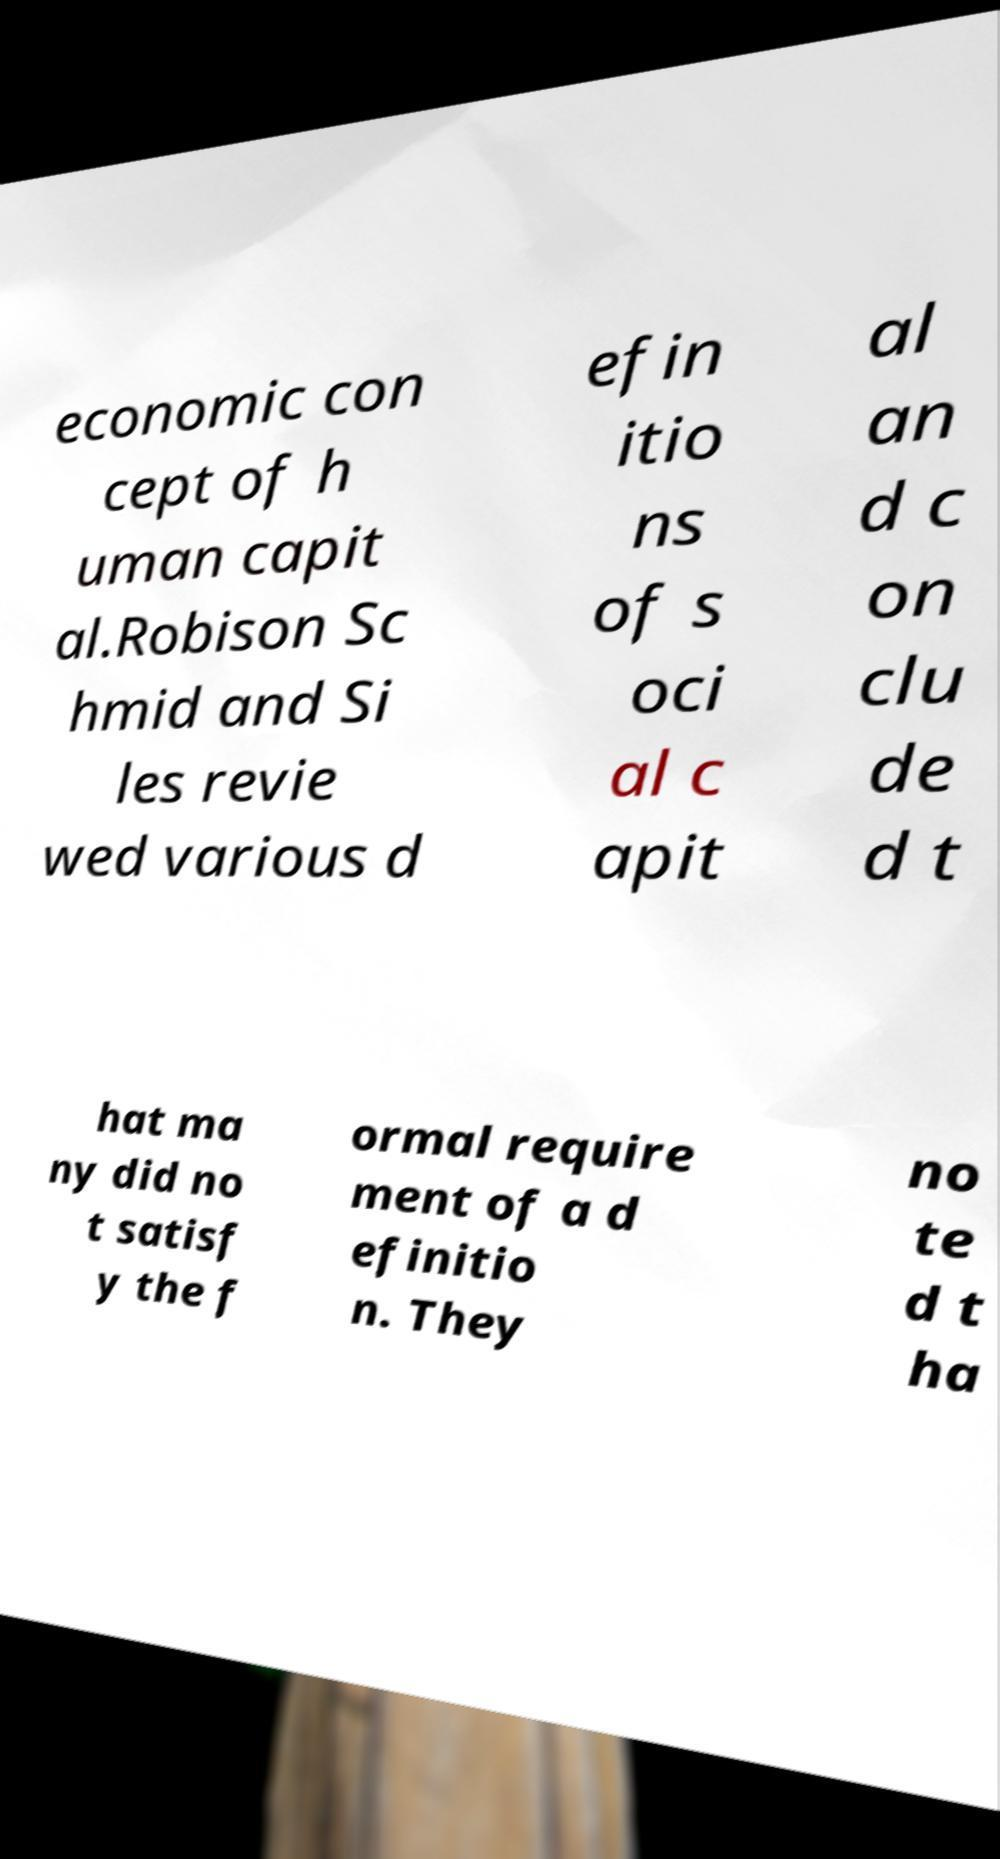Could you extract and type out the text from this image? economic con cept of h uman capit al.Robison Sc hmid and Si les revie wed various d efin itio ns of s oci al c apit al an d c on clu de d t hat ma ny did no t satisf y the f ormal require ment of a d efinitio n. They no te d t ha 